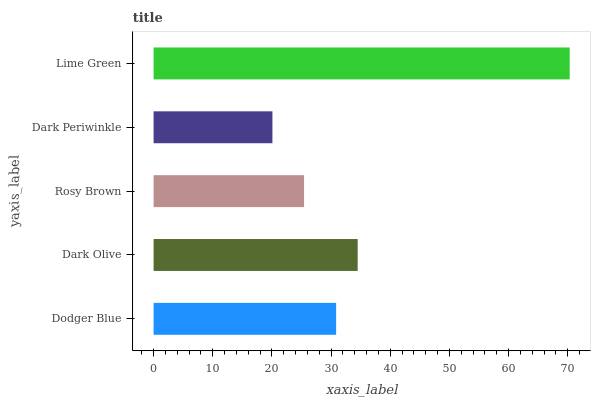Is Dark Periwinkle the minimum?
Answer yes or no. Yes. Is Lime Green the maximum?
Answer yes or no. Yes. Is Dark Olive the minimum?
Answer yes or no. No. Is Dark Olive the maximum?
Answer yes or no. No. Is Dark Olive greater than Dodger Blue?
Answer yes or no. Yes. Is Dodger Blue less than Dark Olive?
Answer yes or no. Yes. Is Dodger Blue greater than Dark Olive?
Answer yes or no. No. Is Dark Olive less than Dodger Blue?
Answer yes or no. No. Is Dodger Blue the high median?
Answer yes or no. Yes. Is Dodger Blue the low median?
Answer yes or no. Yes. Is Lime Green the high median?
Answer yes or no. No. Is Lime Green the low median?
Answer yes or no. No. 